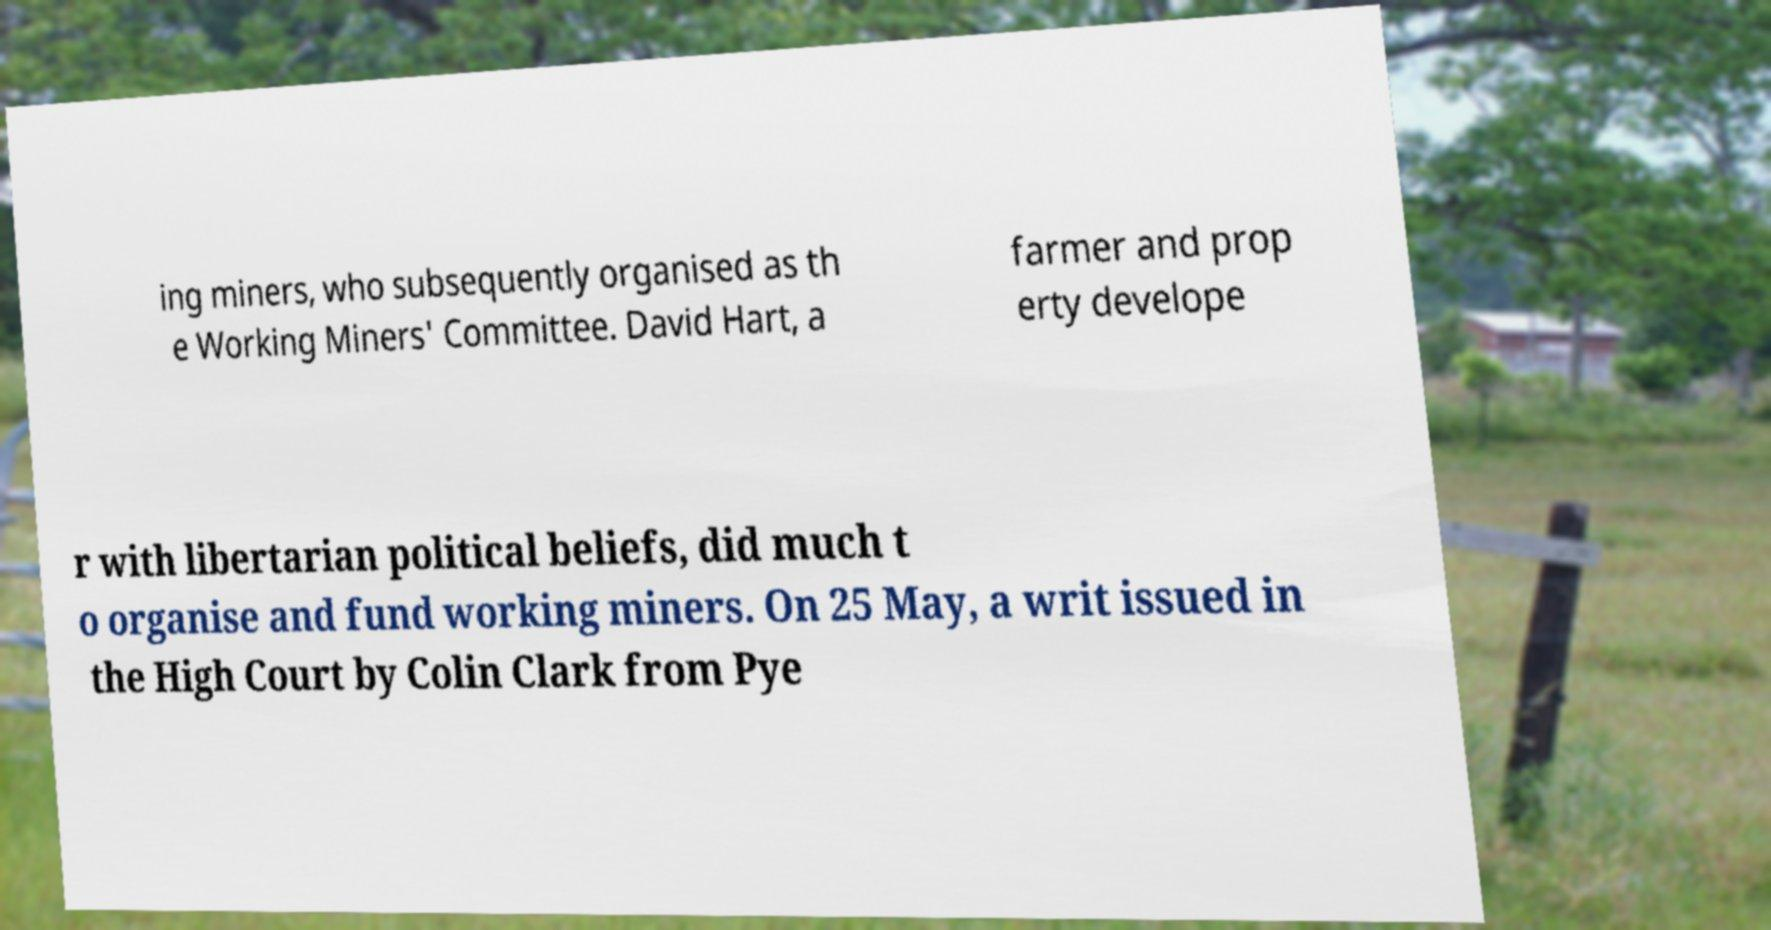Can you read and provide the text displayed in the image?This photo seems to have some interesting text. Can you extract and type it out for me? ing miners, who subsequently organised as th e Working Miners' Committee. David Hart, a farmer and prop erty develope r with libertarian political beliefs, did much t o organise and fund working miners. On 25 May, a writ issued in the High Court by Colin Clark from Pye 